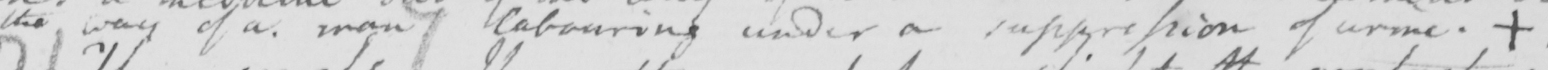Please transcribe the handwritten text in this image. the way of a man labouring under a suppression of urine .  + 